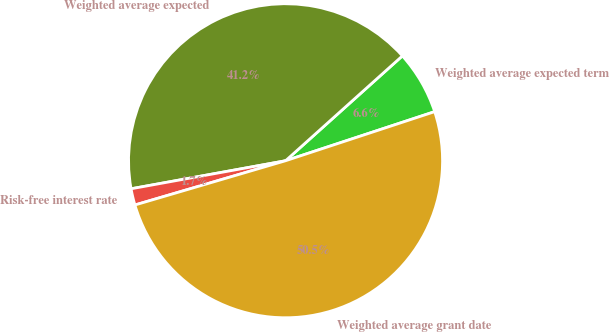<chart> <loc_0><loc_0><loc_500><loc_500><pie_chart><fcel>Weighted average expected term<fcel>Weighted average expected<fcel>Risk-free interest rate<fcel>Weighted average grant date<nl><fcel>6.58%<fcel>41.22%<fcel>1.69%<fcel>50.52%<nl></chart> 